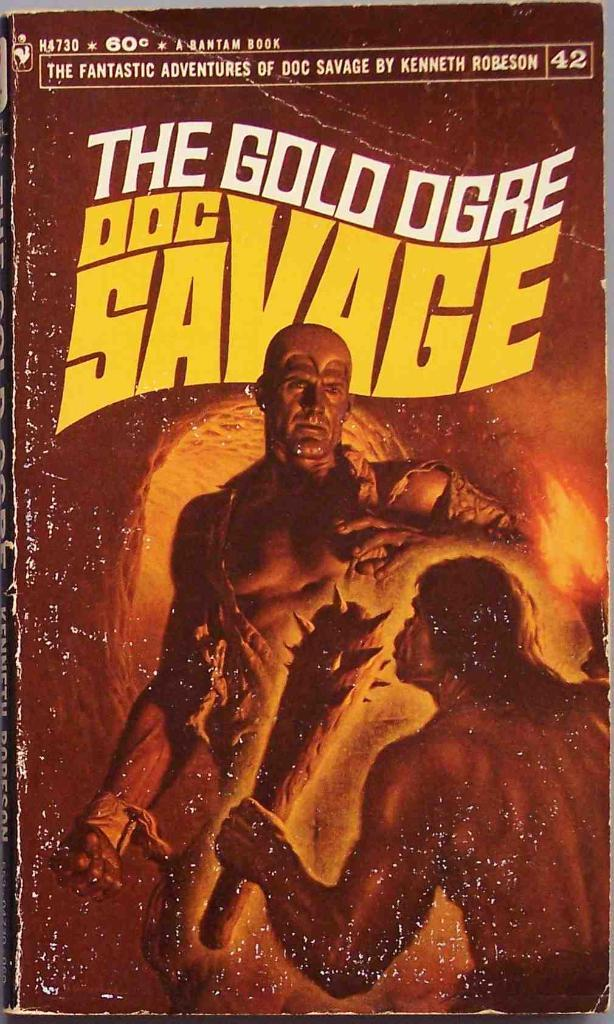<image>
Relay a brief, clear account of the picture shown. A book called The Gold Ogre has a very worn cover 